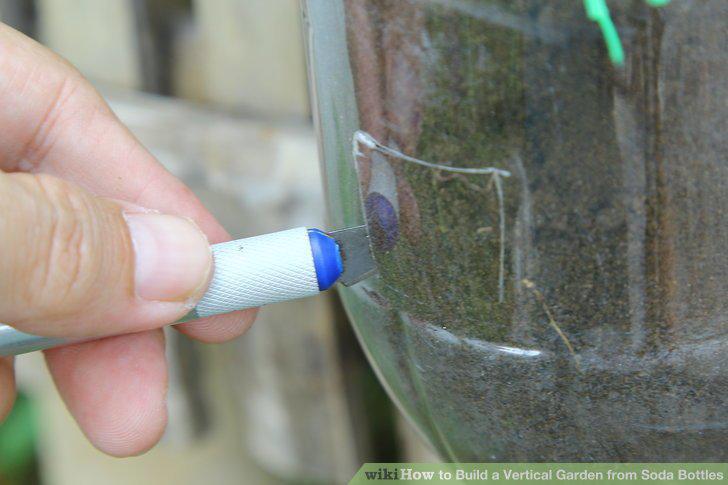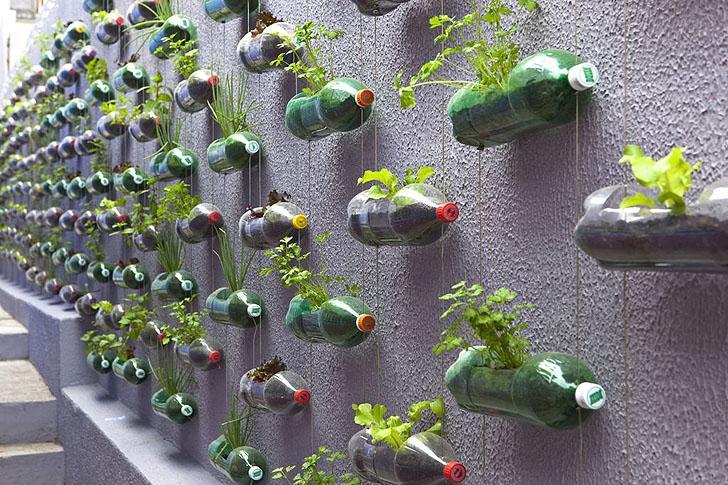The first image is the image on the left, the second image is the image on the right. For the images displayed, is the sentence "The bottles in one of the images are attached to a wall as planters." factually correct? Answer yes or no. Yes. 